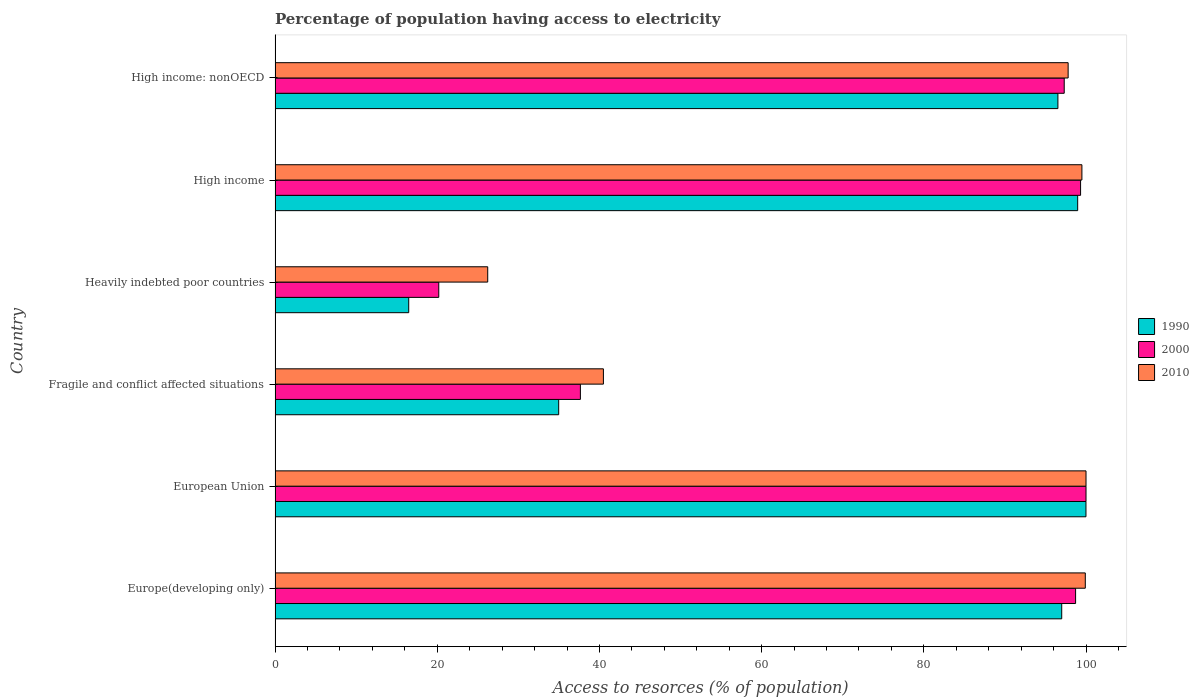How many groups of bars are there?
Provide a short and direct response. 6. Are the number of bars per tick equal to the number of legend labels?
Offer a terse response. Yes. What is the label of the 1st group of bars from the top?
Offer a terse response. High income: nonOECD. In how many cases, is the number of bars for a given country not equal to the number of legend labels?
Keep it short and to the point. 0. What is the percentage of population having access to electricity in 1990 in High income: nonOECD?
Ensure brevity in your answer.  96.53. Across all countries, what is the maximum percentage of population having access to electricity in 2010?
Offer a terse response. 100. Across all countries, what is the minimum percentage of population having access to electricity in 1990?
Your answer should be compact. 16.48. In which country was the percentage of population having access to electricity in 1990 maximum?
Ensure brevity in your answer.  European Union. In which country was the percentage of population having access to electricity in 2010 minimum?
Offer a very short reply. Heavily indebted poor countries. What is the total percentage of population having access to electricity in 1990 in the graph?
Your response must be concise. 443.96. What is the difference between the percentage of population having access to electricity in 1990 in Europe(developing only) and that in High income: nonOECD?
Offer a very short reply. 0.47. What is the difference between the percentage of population having access to electricity in 1990 in High income and the percentage of population having access to electricity in 2000 in Europe(developing only)?
Your answer should be very brief. 0.26. What is the average percentage of population having access to electricity in 2010 per country?
Your answer should be compact. 77.32. What is the difference between the percentage of population having access to electricity in 2000 and percentage of population having access to electricity in 2010 in Europe(developing only)?
Your answer should be very brief. -1.2. What is the ratio of the percentage of population having access to electricity in 1990 in European Union to that in Fragile and conflict affected situations?
Keep it short and to the point. 2.86. Is the percentage of population having access to electricity in 2010 in Fragile and conflict affected situations less than that in High income?
Your response must be concise. Yes. What is the difference between the highest and the second highest percentage of population having access to electricity in 2010?
Provide a short and direct response. 0.09. What is the difference between the highest and the lowest percentage of population having access to electricity in 1990?
Provide a short and direct response. 83.51. How many bars are there?
Make the answer very short. 18. How many countries are there in the graph?
Your response must be concise. 6. What is the title of the graph?
Provide a short and direct response. Percentage of population having access to electricity. What is the label or title of the X-axis?
Offer a very short reply. Access to resorces (% of population). What is the Access to resorces (% of population) of 1990 in Europe(developing only)?
Your answer should be compact. 97. What is the Access to resorces (% of population) in 2000 in Europe(developing only)?
Ensure brevity in your answer.  98.72. What is the Access to resorces (% of population) in 2010 in Europe(developing only)?
Make the answer very short. 99.91. What is the Access to resorces (% of population) in 1990 in European Union?
Offer a terse response. 99.99. What is the Access to resorces (% of population) of 2010 in European Union?
Provide a succinct answer. 100. What is the Access to resorces (% of population) in 1990 in Fragile and conflict affected situations?
Offer a very short reply. 34.97. What is the Access to resorces (% of population) of 2000 in Fragile and conflict affected situations?
Keep it short and to the point. 37.65. What is the Access to resorces (% of population) in 2010 in Fragile and conflict affected situations?
Provide a succinct answer. 40.49. What is the Access to resorces (% of population) of 1990 in Heavily indebted poor countries?
Your response must be concise. 16.48. What is the Access to resorces (% of population) of 2000 in Heavily indebted poor countries?
Ensure brevity in your answer.  20.18. What is the Access to resorces (% of population) of 2010 in Heavily indebted poor countries?
Offer a terse response. 26.22. What is the Access to resorces (% of population) in 1990 in High income?
Offer a terse response. 98.97. What is the Access to resorces (% of population) in 2000 in High income?
Your answer should be compact. 99.33. What is the Access to resorces (% of population) in 2010 in High income?
Provide a short and direct response. 99.49. What is the Access to resorces (% of population) in 1990 in High income: nonOECD?
Your response must be concise. 96.53. What is the Access to resorces (% of population) in 2000 in High income: nonOECD?
Provide a short and direct response. 97.31. What is the Access to resorces (% of population) of 2010 in High income: nonOECD?
Your answer should be compact. 97.8. Across all countries, what is the maximum Access to resorces (% of population) in 1990?
Offer a terse response. 99.99. Across all countries, what is the maximum Access to resorces (% of population) in 2010?
Your answer should be very brief. 100. Across all countries, what is the minimum Access to resorces (% of population) in 1990?
Keep it short and to the point. 16.48. Across all countries, what is the minimum Access to resorces (% of population) in 2000?
Offer a terse response. 20.18. Across all countries, what is the minimum Access to resorces (% of population) of 2010?
Ensure brevity in your answer.  26.22. What is the total Access to resorces (% of population) in 1990 in the graph?
Provide a short and direct response. 443.96. What is the total Access to resorces (% of population) in 2000 in the graph?
Give a very brief answer. 453.19. What is the total Access to resorces (% of population) in 2010 in the graph?
Offer a very short reply. 463.91. What is the difference between the Access to resorces (% of population) of 1990 in Europe(developing only) and that in European Union?
Ensure brevity in your answer.  -2.99. What is the difference between the Access to resorces (% of population) of 2000 in Europe(developing only) and that in European Union?
Ensure brevity in your answer.  -1.28. What is the difference between the Access to resorces (% of population) of 2010 in Europe(developing only) and that in European Union?
Offer a very short reply. -0.09. What is the difference between the Access to resorces (% of population) in 1990 in Europe(developing only) and that in Fragile and conflict affected situations?
Ensure brevity in your answer.  62.03. What is the difference between the Access to resorces (% of population) of 2000 in Europe(developing only) and that in Fragile and conflict affected situations?
Offer a very short reply. 61.07. What is the difference between the Access to resorces (% of population) of 2010 in Europe(developing only) and that in Fragile and conflict affected situations?
Ensure brevity in your answer.  59.42. What is the difference between the Access to resorces (% of population) in 1990 in Europe(developing only) and that in Heavily indebted poor countries?
Keep it short and to the point. 80.52. What is the difference between the Access to resorces (% of population) of 2000 in Europe(developing only) and that in Heavily indebted poor countries?
Offer a terse response. 78.53. What is the difference between the Access to resorces (% of population) of 2010 in Europe(developing only) and that in Heavily indebted poor countries?
Your answer should be very brief. 73.69. What is the difference between the Access to resorces (% of population) in 1990 in Europe(developing only) and that in High income?
Offer a very short reply. -1.97. What is the difference between the Access to resorces (% of population) of 2000 in Europe(developing only) and that in High income?
Make the answer very short. -0.62. What is the difference between the Access to resorces (% of population) of 2010 in Europe(developing only) and that in High income?
Your response must be concise. 0.42. What is the difference between the Access to resorces (% of population) of 1990 in Europe(developing only) and that in High income: nonOECD?
Make the answer very short. 0.47. What is the difference between the Access to resorces (% of population) in 2000 in Europe(developing only) and that in High income: nonOECD?
Ensure brevity in your answer.  1.4. What is the difference between the Access to resorces (% of population) in 2010 in Europe(developing only) and that in High income: nonOECD?
Your answer should be compact. 2.12. What is the difference between the Access to resorces (% of population) in 1990 in European Union and that in Fragile and conflict affected situations?
Give a very brief answer. 65.02. What is the difference between the Access to resorces (% of population) of 2000 in European Union and that in Fragile and conflict affected situations?
Provide a succinct answer. 62.35. What is the difference between the Access to resorces (% of population) in 2010 in European Union and that in Fragile and conflict affected situations?
Ensure brevity in your answer.  59.51. What is the difference between the Access to resorces (% of population) of 1990 in European Union and that in Heavily indebted poor countries?
Make the answer very short. 83.51. What is the difference between the Access to resorces (% of population) in 2000 in European Union and that in Heavily indebted poor countries?
Ensure brevity in your answer.  79.82. What is the difference between the Access to resorces (% of population) in 2010 in European Union and that in Heavily indebted poor countries?
Your answer should be compact. 73.78. What is the difference between the Access to resorces (% of population) in 1990 in European Union and that in High income?
Provide a short and direct response. 1.02. What is the difference between the Access to resorces (% of population) of 2000 in European Union and that in High income?
Your response must be concise. 0.67. What is the difference between the Access to resorces (% of population) of 2010 in European Union and that in High income?
Your answer should be very brief. 0.51. What is the difference between the Access to resorces (% of population) of 1990 in European Union and that in High income: nonOECD?
Your response must be concise. 3.46. What is the difference between the Access to resorces (% of population) of 2000 in European Union and that in High income: nonOECD?
Provide a short and direct response. 2.69. What is the difference between the Access to resorces (% of population) in 2010 in European Union and that in High income: nonOECD?
Keep it short and to the point. 2.2. What is the difference between the Access to resorces (% of population) in 1990 in Fragile and conflict affected situations and that in Heavily indebted poor countries?
Your answer should be very brief. 18.49. What is the difference between the Access to resorces (% of population) of 2000 in Fragile and conflict affected situations and that in Heavily indebted poor countries?
Ensure brevity in your answer.  17.46. What is the difference between the Access to resorces (% of population) in 2010 in Fragile and conflict affected situations and that in Heavily indebted poor countries?
Give a very brief answer. 14.27. What is the difference between the Access to resorces (% of population) of 1990 in Fragile and conflict affected situations and that in High income?
Your response must be concise. -64. What is the difference between the Access to resorces (% of population) of 2000 in Fragile and conflict affected situations and that in High income?
Offer a very short reply. -61.68. What is the difference between the Access to resorces (% of population) of 2010 in Fragile and conflict affected situations and that in High income?
Give a very brief answer. -59.01. What is the difference between the Access to resorces (% of population) in 1990 in Fragile and conflict affected situations and that in High income: nonOECD?
Offer a terse response. -61.56. What is the difference between the Access to resorces (% of population) of 2000 in Fragile and conflict affected situations and that in High income: nonOECD?
Your answer should be very brief. -59.67. What is the difference between the Access to resorces (% of population) in 2010 in Fragile and conflict affected situations and that in High income: nonOECD?
Offer a terse response. -57.31. What is the difference between the Access to resorces (% of population) of 1990 in Heavily indebted poor countries and that in High income?
Your response must be concise. -82.49. What is the difference between the Access to resorces (% of population) in 2000 in Heavily indebted poor countries and that in High income?
Offer a terse response. -79.15. What is the difference between the Access to resorces (% of population) in 2010 in Heavily indebted poor countries and that in High income?
Give a very brief answer. -73.27. What is the difference between the Access to resorces (% of population) in 1990 in Heavily indebted poor countries and that in High income: nonOECD?
Make the answer very short. -80.05. What is the difference between the Access to resorces (% of population) in 2000 in Heavily indebted poor countries and that in High income: nonOECD?
Provide a succinct answer. -77.13. What is the difference between the Access to resorces (% of population) in 2010 in Heavily indebted poor countries and that in High income: nonOECD?
Your answer should be compact. -71.58. What is the difference between the Access to resorces (% of population) in 1990 in High income and that in High income: nonOECD?
Offer a very short reply. 2.44. What is the difference between the Access to resorces (% of population) of 2000 in High income and that in High income: nonOECD?
Make the answer very short. 2.02. What is the difference between the Access to resorces (% of population) in 2010 in High income and that in High income: nonOECD?
Your answer should be very brief. 1.7. What is the difference between the Access to resorces (% of population) of 1990 in Europe(developing only) and the Access to resorces (% of population) of 2000 in European Union?
Your answer should be very brief. -3. What is the difference between the Access to resorces (% of population) of 1990 in Europe(developing only) and the Access to resorces (% of population) of 2010 in European Union?
Your response must be concise. -3. What is the difference between the Access to resorces (% of population) of 2000 in Europe(developing only) and the Access to resorces (% of population) of 2010 in European Union?
Your answer should be compact. -1.28. What is the difference between the Access to resorces (% of population) in 1990 in Europe(developing only) and the Access to resorces (% of population) in 2000 in Fragile and conflict affected situations?
Give a very brief answer. 59.36. What is the difference between the Access to resorces (% of population) of 1990 in Europe(developing only) and the Access to resorces (% of population) of 2010 in Fragile and conflict affected situations?
Offer a very short reply. 56.52. What is the difference between the Access to resorces (% of population) of 2000 in Europe(developing only) and the Access to resorces (% of population) of 2010 in Fragile and conflict affected situations?
Offer a terse response. 58.23. What is the difference between the Access to resorces (% of population) in 1990 in Europe(developing only) and the Access to resorces (% of population) in 2000 in Heavily indebted poor countries?
Give a very brief answer. 76.82. What is the difference between the Access to resorces (% of population) in 1990 in Europe(developing only) and the Access to resorces (% of population) in 2010 in Heavily indebted poor countries?
Provide a succinct answer. 70.78. What is the difference between the Access to resorces (% of population) of 2000 in Europe(developing only) and the Access to resorces (% of population) of 2010 in Heavily indebted poor countries?
Your answer should be very brief. 72.49. What is the difference between the Access to resorces (% of population) in 1990 in Europe(developing only) and the Access to resorces (% of population) in 2000 in High income?
Make the answer very short. -2.33. What is the difference between the Access to resorces (% of population) of 1990 in Europe(developing only) and the Access to resorces (% of population) of 2010 in High income?
Keep it short and to the point. -2.49. What is the difference between the Access to resorces (% of population) of 2000 in Europe(developing only) and the Access to resorces (% of population) of 2010 in High income?
Your answer should be very brief. -0.78. What is the difference between the Access to resorces (% of population) in 1990 in Europe(developing only) and the Access to resorces (% of population) in 2000 in High income: nonOECD?
Offer a terse response. -0.31. What is the difference between the Access to resorces (% of population) in 1990 in Europe(developing only) and the Access to resorces (% of population) in 2010 in High income: nonOECD?
Give a very brief answer. -0.79. What is the difference between the Access to resorces (% of population) of 2000 in Europe(developing only) and the Access to resorces (% of population) of 2010 in High income: nonOECD?
Keep it short and to the point. 0.92. What is the difference between the Access to resorces (% of population) in 1990 in European Union and the Access to resorces (% of population) in 2000 in Fragile and conflict affected situations?
Your answer should be very brief. 62.35. What is the difference between the Access to resorces (% of population) in 1990 in European Union and the Access to resorces (% of population) in 2010 in Fragile and conflict affected situations?
Your response must be concise. 59.51. What is the difference between the Access to resorces (% of population) of 2000 in European Union and the Access to resorces (% of population) of 2010 in Fragile and conflict affected situations?
Offer a very short reply. 59.51. What is the difference between the Access to resorces (% of population) in 1990 in European Union and the Access to resorces (% of population) in 2000 in Heavily indebted poor countries?
Your answer should be compact. 79.81. What is the difference between the Access to resorces (% of population) in 1990 in European Union and the Access to resorces (% of population) in 2010 in Heavily indebted poor countries?
Provide a succinct answer. 73.77. What is the difference between the Access to resorces (% of population) in 2000 in European Union and the Access to resorces (% of population) in 2010 in Heavily indebted poor countries?
Give a very brief answer. 73.78. What is the difference between the Access to resorces (% of population) of 1990 in European Union and the Access to resorces (% of population) of 2000 in High income?
Ensure brevity in your answer.  0.66. What is the difference between the Access to resorces (% of population) in 1990 in European Union and the Access to resorces (% of population) in 2010 in High income?
Provide a succinct answer. 0.5. What is the difference between the Access to resorces (% of population) of 2000 in European Union and the Access to resorces (% of population) of 2010 in High income?
Offer a terse response. 0.51. What is the difference between the Access to resorces (% of population) of 1990 in European Union and the Access to resorces (% of population) of 2000 in High income: nonOECD?
Offer a terse response. 2.68. What is the difference between the Access to resorces (% of population) in 1990 in European Union and the Access to resorces (% of population) in 2010 in High income: nonOECD?
Keep it short and to the point. 2.2. What is the difference between the Access to resorces (% of population) of 2000 in European Union and the Access to resorces (% of population) of 2010 in High income: nonOECD?
Your answer should be very brief. 2.2. What is the difference between the Access to resorces (% of population) of 1990 in Fragile and conflict affected situations and the Access to resorces (% of population) of 2000 in Heavily indebted poor countries?
Ensure brevity in your answer.  14.79. What is the difference between the Access to resorces (% of population) in 1990 in Fragile and conflict affected situations and the Access to resorces (% of population) in 2010 in Heavily indebted poor countries?
Keep it short and to the point. 8.75. What is the difference between the Access to resorces (% of population) of 2000 in Fragile and conflict affected situations and the Access to resorces (% of population) of 2010 in Heavily indebted poor countries?
Your response must be concise. 11.43. What is the difference between the Access to resorces (% of population) of 1990 in Fragile and conflict affected situations and the Access to resorces (% of population) of 2000 in High income?
Offer a terse response. -64.36. What is the difference between the Access to resorces (% of population) of 1990 in Fragile and conflict affected situations and the Access to resorces (% of population) of 2010 in High income?
Your answer should be compact. -64.52. What is the difference between the Access to resorces (% of population) in 2000 in Fragile and conflict affected situations and the Access to resorces (% of population) in 2010 in High income?
Keep it short and to the point. -61.85. What is the difference between the Access to resorces (% of population) in 1990 in Fragile and conflict affected situations and the Access to resorces (% of population) in 2000 in High income: nonOECD?
Your answer should be very brief. -62.34. What is the difference between the Access to resorces (% of population) in 1990 in Fragile and conflict affected situations and the Access to resorces (% of population) in 2010 in High income: nonOECD?
Give a very brief answer. -62.82. What is the difference between the Access to resorces (% of population) in 2000 in Fragile and conflict affected situations and the Access to resorces (% of population) in 2010 in High income: nonOECD?
Provide a succinct answer. -60.15. What is the difference between the Access to resorces (% of population) in 1990 in Heavily indebted poor countries and the Access to resorces (% of population) in 2000 in High income?
Ensure brevity in your answer.  -82.85. What is the difference between the Access to resorces (% of population) of 1990 in Heavily indebted poor countries and the Access to resorces (% of population) of 2010 in High income?
Your answer should be very brief. -83.01. What is the difference between the Access to resorces (% of population) of 2000 in Heavily indebted poor countries and the Access to resorces (% of population) of 2010 in High income?
Offer a terse response. -79.31. What is the difference between the Access to resorces (% of population) of 1990 in Heavily indebted poor countries and the Access to resorces (% of population) of 2000 in High income: nonOECD?
Your answer should be very brief. -80.83. What is the difference between the Access to resorces (% of population) of 1990 in Heavily indebted poor countries and the Access to resorces (% of population) of 2010 in High income: nonOECD?
Your response must be concise. -81.32. What is the difference between the Access to resorces (% of population) of 2000 in Heavily indebted poor countries and the Access to resorces (% of population) of 2010 in High income: nonOECD?
Offer a very short reply. -77.61. What is the difference between the Access to resorces (% of population) of 1990 in High income and the Access to resorces (% of population) of 2000 in High income: nonOECD?
Ensure brevity in your answer.  1.66. What is the difference between the Access to resorces (% of population) in 1990 in High income and the Access to resorces (% of population) in 2010 in High income: nonOECD?
Your answer should be compact. 1.18. What is the difference between the Access to resorces (% of population) in 2000 in High income and the Access to resorces (% of population) in 2010 in High income: nonOECD?
Ensure brevity in your answer.  1.53. What is the average Access to resorces (% of population) in 1990 per country?
Your response must be concise. 73.99. What is the average Access to resorces (% of population) of 2000 per country?
Keep it short and to the point. 75.53. What is the average Access to resorces (% of population) of 2010 per country?
Offer a very short reply. 77.32. What is the difference between the Access to resorces (% of population) in 1990 and Access to resorces (% of population) in 2000 in Europe(developing only)?
Your answer should be very brief. -1.71. What is the difference between the Access to resorces (% of population) in 1990 and Access to resorces (% of population) in 2010 in Europe(developing only)?
Ensure brevity in your answer.  -2.91. What is the difference between the Access to resorces (% of population) of 2000 and Access to resorces (% of population) of 2010 in Europe(developing only)?
Give a very brief answer. -1.2. What is the difference between the Access to resorces (% of population) in 1990 and Access to resorces (% of population) in 2000 in European Union?
Ensure brevity in your answer.  -0.01. What is the difference between the Access to resorces (% of population) in 1990 and Access to resorces (% of population) in 2010 in European Union?
Your answer should be very brief. -0.01. What is the difference between the Access to resorces (% of population) of 1990 and Access to resorces (% of population) of 2000 in Fragile and conflict affected situations?
Give a very brief answer. -2.68. What is the difference between the Access to resorces (% of population) in 1990 and Access to resorces (% of population) in 2010 in Fragile and conflict affected situations?
Offer a terse response. -5.51. What is the difference between the Access to resorces (% of population) of 2000 and Access to resorces (% of population) of 2010 in Fragile and conflict affected situations?
Your answer should be very brief. -2.84. What is the difference between the Access to resorces (% of population) of 1990 and Access to resorces (% of population) of 2000 in Heavily indebted poor countries?
Offer a very short reply. -3.7. What is the difference between the Access to resorces (% of population) in 1990 and Access to resorces (% of population) in 2010 in Heavily indebted poor countries?
Ensure brevity in your answer.  -9.74. What is the difference between the Access to resorces (% of population) in 2000 and Access to resorces (% of population) in 2010 in Heavily indebted poor countries?
Ensure brevity in your answer.  -6.04. What is the difference between the Access to resorces (% of population) of 1990 and Access to resorces (% of population) of 2000 in High income?
Keep it short and to the point. -0.36. What is the difference between the Access to resorces (% of population) in 1990 and Access to resorces (% of population) in 2010 in High income?
Ensure brevity in your answer.  -0.52. What is the difference between the Access to resorces (% of population) of 2000 and Access to resorces (% of population) of 2010 in High income?
Your response must be concise. -0.16. What is the difference between the Access to resorces (% of population) of 1990 and Access to resorces (% of population) of 2000 in High income: nonOECD?
Your response must be concise. -0.78. What is the difference between the Access to resorces (% of population) in 1990 and Access to resorces (% of population) in 2010 in High income: nonOECD?
Keep it short and to the point. -1.26. What is the difference between the Access to resorces (% of population) of 2000 and Access to resorces (% of population) of 2010 in High income: nonOECD?
Offer a terse response. -0.48. What is the ratio of the Access to resorces (% of population) of 1990 in Europe(developing only) to that in European Union?
Your answer should be compact. 0.97. What is the ratio of the Access to resorces (% of population) of 2000 in Europe(developing only) to that in European Union?
Provide a succinct answer. 0.99. What is the ratio of the Access to resorces (% of population) in 2010 in Europe(developing only) to that in European Union?
Offer a terse response. 1. What is the ratio of the Access to resorces (% of population) of 1990 in Europe(developing only) to that in Fragile and conflict affected situations?
Provide a succinct answer. 2.77. What is the ratio of the Access to resorces (% of population) of 2000 in Europe(developing only) to that in Fragile and conflict affected situations?
Provide a short and direct response. 2.62. What is the ratio of the Access to resorces (% of population) of 2010 in Europe(developing only) to that in Fragile and conflict affected situations?
Provide a short and direct response. 2.47. What is the ratio of the Access to resorces (% of population) in 1990 in Europe(developing only) to that in Heavily indebted poor countries?
Provide a short and direct response. 5.89. What is the ratio of the Access to resorces (% of population) in 2000 in Europe(developing only) to that in Heavily indebted poor countries?
Ensure brevity in your answer.  4.89. What is the ratio of the Access to resorces (% of population) in 2010 in Europe(developing only) to that in Heavily indebted poor countries?
Your answer should be very brief. 3.81. What is the ratio of the Access to resorces (% of population) of 1990 in Europe(developing only) to that in High income?
Give a very brief answer. 0.98. What is the ratio of the Access to resorces (% of population) of 2000 in Europe(developing only) to that in High income: nonOECD?
Your response must be concise. 1.01. What is the ratio of the Access to resorces (% of population) of 2010 in Europe(developing only) to that in High income: nonOECD?
Your response must be concise. 1.02. What is the ratio of the Access to resorces (% of population) in 1990 in European Union to that in Fragile and conflict affected situations?
Make the answer very short. 2.86. What is the ratio of the Access to resorces (% of population) in 2000 in European Union to that in Fragile and conflict affected situations?
Provide a succinct answer. 2.66. What is the ratio of the Access to resorces (% of population) in 2010 in European Union to that in Fragile and conflict affected situations?
Offer a very short reply. 2.47. What is the ratio of the Access to resorces (% of population) in 1990 in European Union to that in Heavily indebted poor countries?
Offer a terse response. 6.07. What is the ratio of the Access to resorces (% of population) of 2000 in European Union to that in Heavily indebted poor countries?
Provide a short and direct response. 4.95. What is the ratio of the Access to resorces (% of population) in 2010 in European Union to that in Heavily indebted poor countries?
Offer a terse response. 3.81. What is the ratio of the Access to resorces (% of population) of 1990 in European Union to that in High income?
Ensure brevity in your answer.  1.01. What is the ratio of the Access to resorces (% of population) in 1990 in European Union to that in High income: nonOECD?
Ensure brevity in your answer.  1.04. What is the ratio of the Access to resorces (% of population) of 2000 in European Union to that in High income: nonOECD?
Provide a short and direct response. 1.03. What is the ratio of the Access to resorces (% of population) in 2010 in European Union to that in High income: nonOECD?
Your answer should be compact. 1.02. What is the ratio of the Access to resorces (% of population) in 1990 in Fragile and conflict affected situations to that in Heavily indebted poor countries?
Keep it short and to the point. 2.12. What is the ratio of the Access to resorces (% of population) in 2000 in Fragile and conflict affected situations to that in Heavily indebted poor countries?
Keep it short and to the point. 1.87. What is the ratio of the Access to resorces (% of population) of 2010 in Fragile and conflict affected situations to that in Heavily indebted poor countries?
Make the answer very short. 1.54. What is the ratio of the Access to resorces (% of population) in 1990 in Fragile and conflict affected situations to that in High income?
Your answer should be compact. 0.35. What is the ratio of the Access to resorces (% of population) of 2000 in Fragile and conflict affected situations to that in High income?
Offer a very short reply. 0.38. What is the ratio of the Access to resorces (% of population) in 2010 in Fragile and conflict affected situations to that in High income?
Make the answer very short. 0.41. What is the ratio of the Access to resorces (% of population) in 1990 in Fragile and conflict affected situations to that in High income: nonOECD?
Your answer should be compact. 0.36. What is the ratio of the Access to resorces (% of population) in 2000 in Fragile and conflict affected situations to that in High income: nonOECD?
Your answer should be very brief. 0.39. What is the ratio of the Access to resorces (% of population) in 2010 in Fragile and conflict affected situations to that in High income: nonOECD?
Your answer should be very brief. 0.41. What is the ratio of the Access to resorces (% of population) of 1990 in Heavily indebted poor countries to that in High income?
Offer a terse response. 0.17. What is the ratio of the Access to resorces (% of population) in 2000 in Heavily indebted poor countries to that in High income?
Offer a terse response. 0.2. What is the ratio of the Access to resorces (% of population) in 2010 in Heavily indebted poor countries to that in High income?
Offer a terse response. 0.26. What is the ratio of the Access to resorces (% of population) in 1990 in Heavily indebted poor countries to that in High income: nonOECD?
Provide a succinct answer. 0.17. What is the ratio of the Access to resorces (% of population) in 2000 in Heavily indebted poor countries to that in High income: nonOECD?
Keep it short and to the point. 0.21. What is the ratio of the Access to resorces (% of population) in 2010 in Heavily indebted poor countries to that in High income: nonOECD?
Provide a succinct answer. 0.27. What is the ratio of the Access to resorces (% of population) in 1990 in High income to that in High income: nonOECD?
Your answer should be compact. 1.03. What is the ratio of the Access to resorces (% of population) of 2000 in High income to that in High income: nonOECD?
Provide a succinct answer. 1.02. What is the ratio of the Access to resorces (% of population) in 2010 in High income to that in High income: nonOECD?
Provide a short and direct response. 1.02. What is the difference between the highest and the second highest Access to resorces (% of population) of 1990?
Your response must be concise. 1.02. What is the difference between the highest and the second highest Access to resorces (% of population) of 2000?
Provide a succinct answer. 0.67. What is the difference between the highest and the second highest Access to resorces (% of population) in 2010?
Ensure brevity in your answer.  0.09. What is the difference between the highest and the lowest Access to resorces (% of population) in 1990?
Provide a short and direct response. 83.51. What is the difference between the highest and the lowest Access to resorces (% of population) in 2000?
Your response must be concise. 79.82. What is the difference between the highest and the lowest Access to resorces (% of population) in 2010?
Keep it short and to the point. 73.78. 